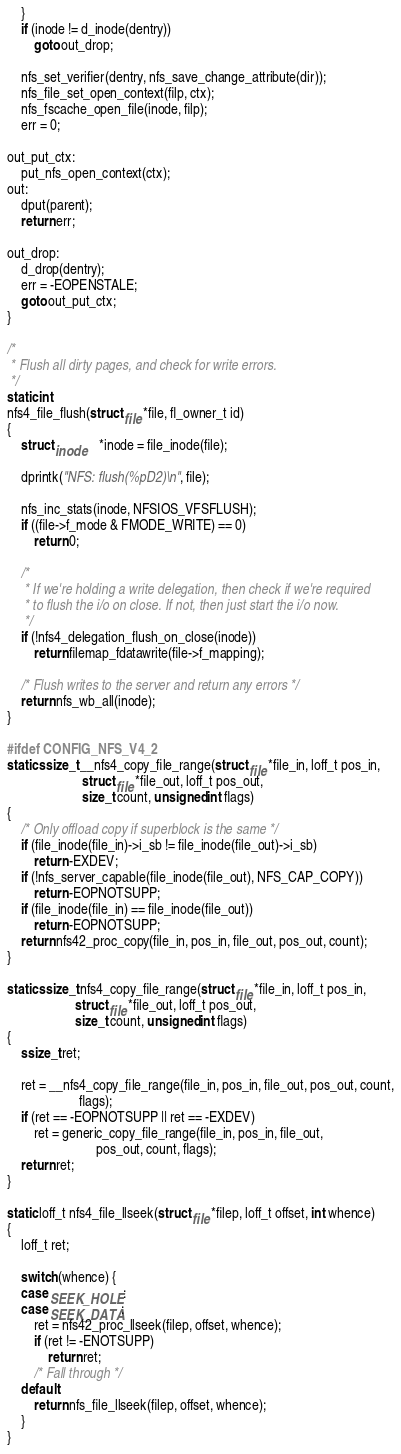<code> <loc_0><loc_0><loc_500><loc_500><_C_>	}
	if (inode != d_inode(dentry))
		goto out_drop;

	nfs_set_verifier(dentry, nfs_save_change_attribute(dir));
	nfs_file_set_open_context(filp, ctx);
	nfs_fscache_open_file(inode, filp);
	err = 0;

out_put_ctx:
	put_nfs_open_context(ctx);
out:
	dput(parent);
	return err;

out_drop:
	d_drop(dentry);
	err = -EOPENSTALE;
	goto out_put_ctx;
}

/*
 * Flush all dirty pages, and check for write errors.
 */
static int
nfs4_file_flush(struct file *file, fl_owner_t id)
{
	struct inode	*inode = file_inode(file);

	dprintk("NFS: flush(%pD2)\n", file);

	nfs_inc_stats(inode, NFSIOS_VFSFLUSH);
	if ((file->f_mode & FMODE_WRITE) == 0)
		return 0;

	/*
	 * If we're holding a write delegation, then check if we're required
	 * to flush the i/o on close. If not, then just start the i/o now.
	 */
	if (!nfs4_delegation_flush_on_close(inode))
		return filemap_fdatawrite(file->f_mapping);

	/* Flush writes to the server and return any errors */
	return nfs_wb_all(inode);
}

#ifdef CONFIG_NFS_V4_2
static ssize_t __nfs4_copy_file_range(struct file *file_in, loff_t pos_in,
				      struct file *file_out, loff_t pos_out,
				      size_t count, unsigned int flags)
{
	/* Only offload copy if superblock is the same */
	if (file_inode(file_in)->i_sb != file_inode(file_out)->i_sb)
		return -EXDEV;
	if (!nfs_server_capable(file_inode(file_out), NFS_CAP_COPY))
		return -EOPNOTSUPP;
	if (file_inode(file_in) == file_inode(file_out))
		return -EOPNOTSUPP;
	return nfs42_proc_copy(file_in, pos_in, file_out, pos_out, count);
}

static ssize_t nfs4_copy_file_range(struct file *file_in, loff_t pos_in,
				    struct file *file_out, loff_t pos_out,
				    size_t count, unsigned int flags)
{
	ssize_t ret;

	ret = __nfs4_copy_file_range(file_in, pos_in, file_out, pos_out, count,
				     flags);
	if (ret == -EOPNOTSUPP || ret == -EXDEV)
		ret = generic_copy_file_range(file_in, pos_in, file_out,
					      pos_out, count, flags);
	return ret;
}

static loff_t nfs4_file_llseek(struct file *filep, loff_t offset, int whence)
{
	loff_t ret;

	switch (whence) {
	case SEEK_HOLE:
	case SEEK_DATA:
		ret = nfs42_proc_llseek(filep, offset, whence);
		if (ret != -ENOTSUPP)
			return ret;
		/* Fall through */
	default:
		return nfs_file_llseek(filep, offset, whence);
	}
}
</code> 